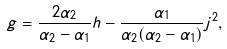<formula> <loc_0><loc_0><loc_500><loc_500>g = \frac { 2 \alpha _ { 2 } } { \alpha _ { 2 } - \alpha _ { 1 } } h - \frac { \alpha _ { 1 } } { \alpha _ { 2 } ( \alpha _ { 2 } - \alpha _ { 1 } ) } j ^ { 2 } ,</formula> 